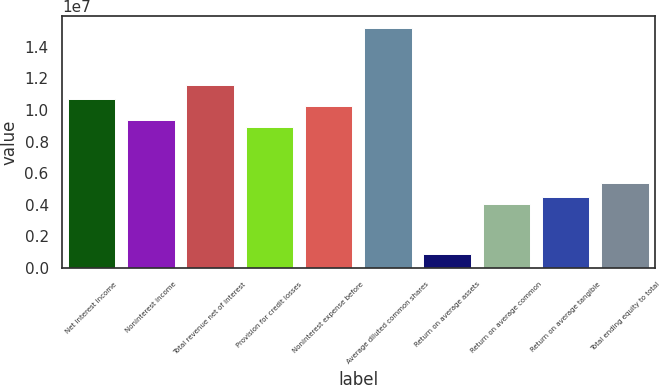Convert chart. <chart><loc_0><loc_0><loc_500><loc_500><bar_chart><fcel>Net interest income<fcel>Noninterest income<fcel>Total revenue net of interest<fcel>Provision for credit losses<fcel>Noninterest expense before<fcel>Average diluted common shares<fcel>Return on average assets<fcel>Return on average common<fcel>Return on average tangible<fcel>Total ending equity to total<nl><fcel>1.07069e+07<fcel>9.36852e+06<fcel>1.15991e+07<fcel>8.9224e+06<fcel>1.02608e+07<fcel>1.51681e+07<fcel>892240<fcel>4.01508e+06<fcel>4.4612e+06<fcel>5.35344e+06<nl></chart> 